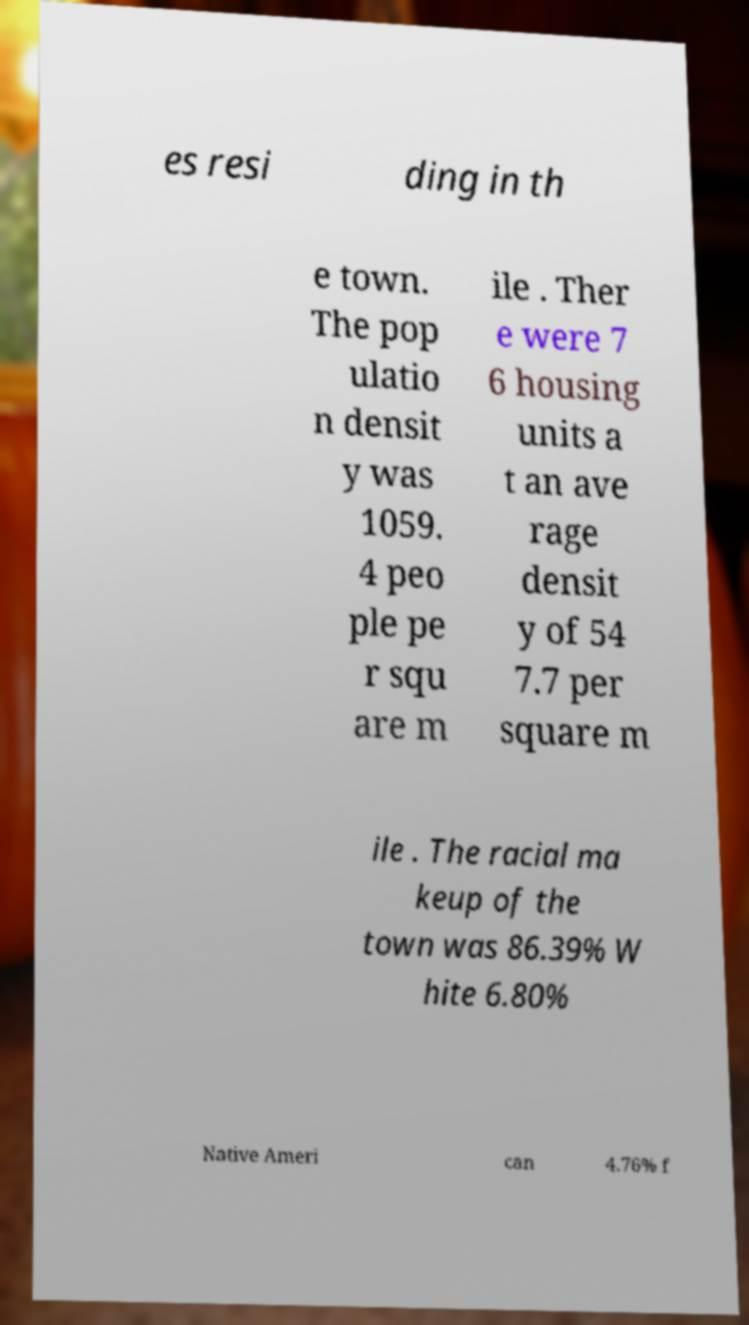Can you read and provide the text displayed in the image?This photo seems to have some interesting text. Can you extract and type it out for me? es resi ding in th e town. The pop ulatio n densit y was 1059. 4 peo ple pe r squ are m ile . Ther e were 7 6 housing units a t an ave rage densit y of 54 7.7 per square m ile . The racial ma keup of the town was 86.39% W hite 6.80% Native Ameri can 4.76% f 